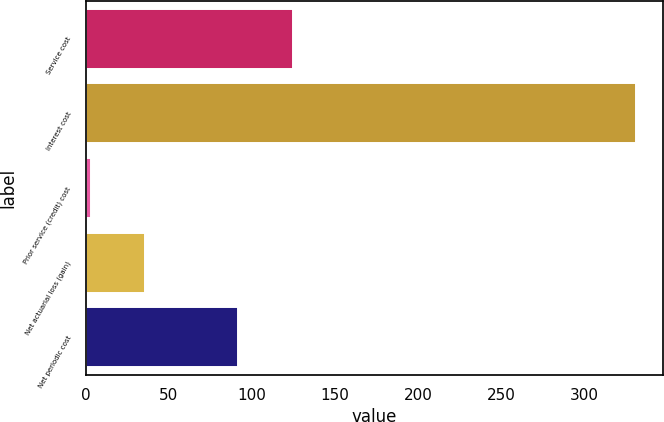<chart> <loc_0><loc_0><loc_500><loc_500><bar_chart><fcel>Service cost<fcel>Interest cost<fcel>Prior service (credit) cost<fcel>Net actuarial loss (gain)<fcel>Net periodic cost<nl><fcel>125<fcel>331<fcel>3<fcel>35.8<fcel>92<nl></chart> 